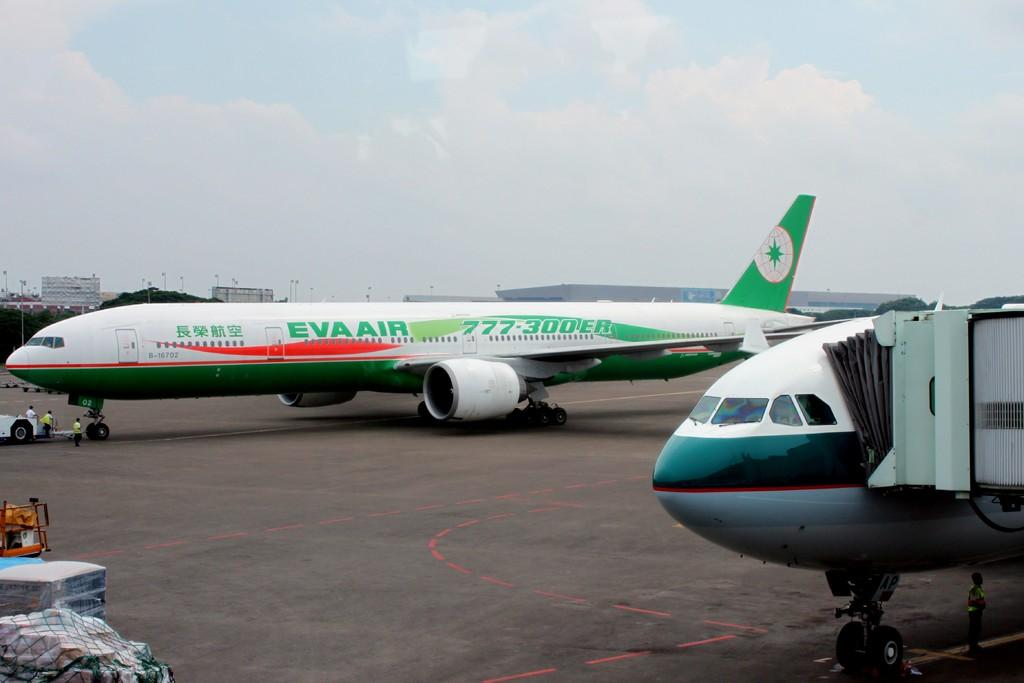Provide a one-sentence caption for the provided image. A white and gree Eva AIr jet liner sits on an airport parking bay next to another plane which is being boarded. 